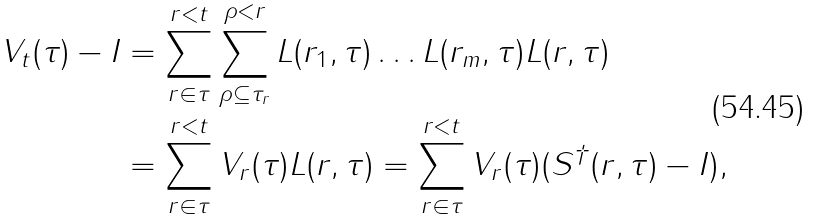Convert formula to latex. <formula><loc_0><loc_0><loc_500><loc_500>V _ { t } ( \tau ) - I & = \sum _ { r \in \tau } ^ { r < t } \sum _ { \rho \subseteq \tau _ { r } } ^ { \rho < r } L ( r _ { 1 } , \tau ) \dots L ( r _ { m } , \tau ) L ( r , \tau ) \\ & = \sum _ { r \in \tau } ^ { r < t } V _ { r } ( \tau ) L ( r , \tau ) = \sum _ { r \in \tau } ^ { r < t } V _ { r } ( \tau ) ( S ^ { \dagger } ( r , \tau ) - I ) ,</formula> 